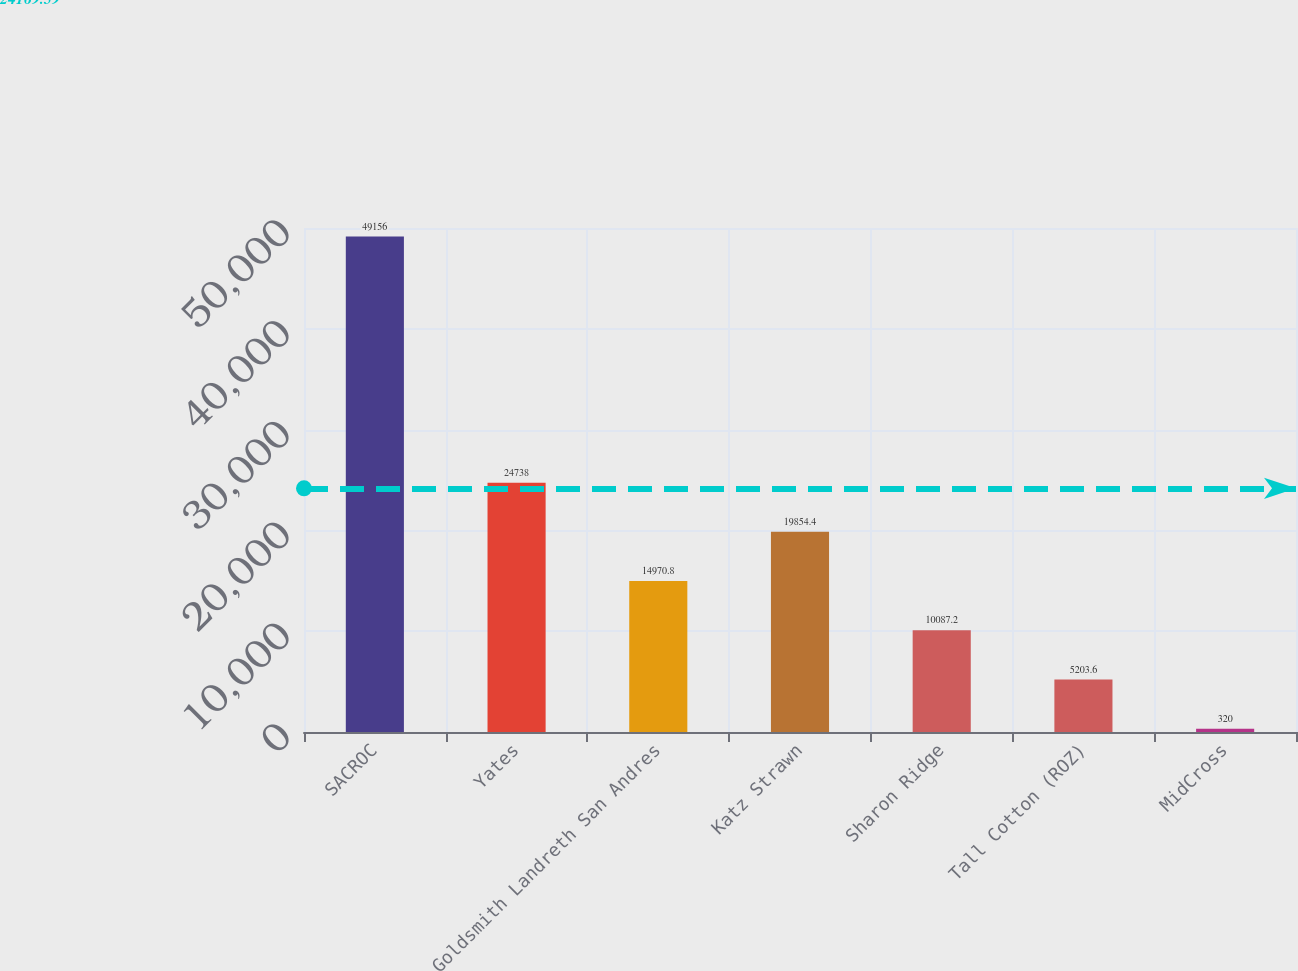Convert chart. <chart><loc_0><loc_0><loc_500><loc_500><bar_chart><fcel>SACROC<fcel>Yates<fcel>Goldsmith Landreth San Andres<fcel>Katz Strawn<fcel>Sharon Ridge<fcel>Tall Cotton (ROZ)<fcel>MidCross<nl><fcel>49156<fcel>24738<fcel>14970.8<fcel>19854.4<fcel>10087.2<fcel>5203.6<fcel>320<nl></chart> 